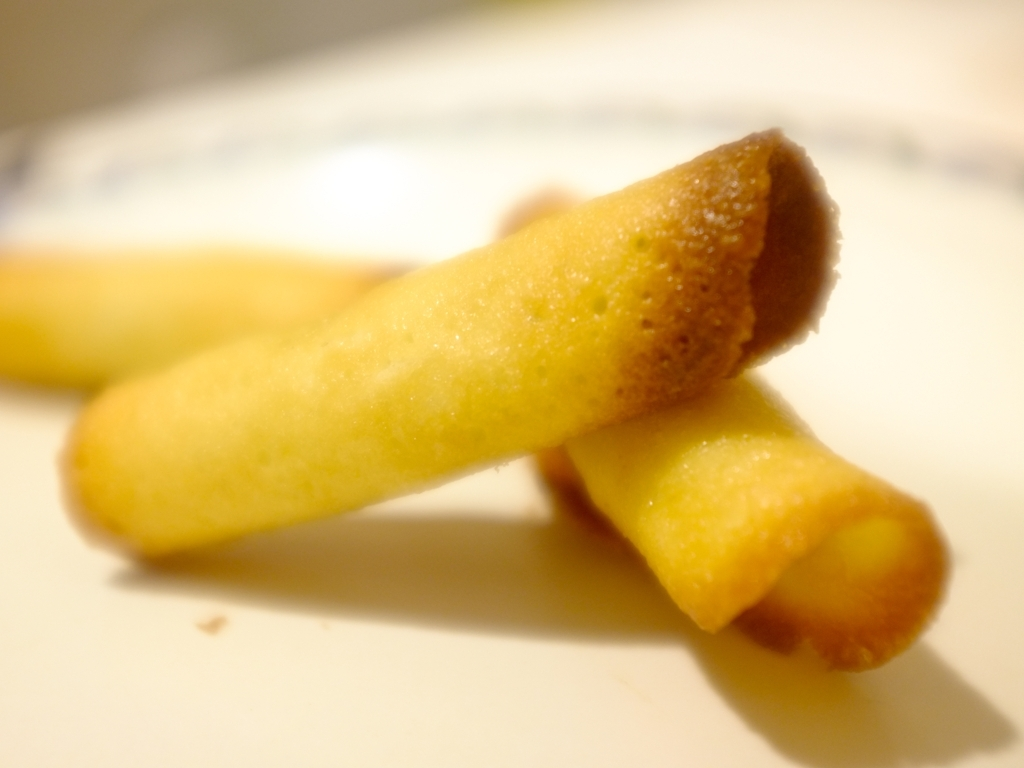Are the features of the image fuzzy? The image does indeed have a soft-focus effect, which results in the features appearing slightly blurred or fuzzy. This could be an artistic choice to emphasize the foreground object, or a result of using a shallow depth of field in the photography process. 